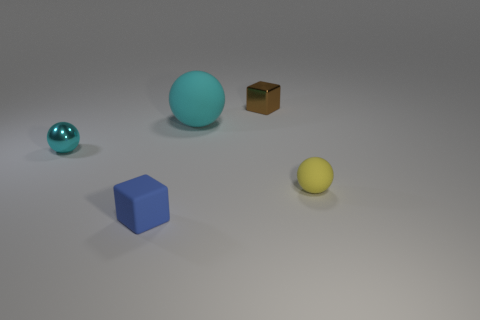There is a metallic block that is the same size as the cyan shiny ball; what is its color?
Provide a succinct answer. Brown. Is the large object made of the same material as the small yellow ball?
Give a very brief answer. Yes. There is a tiny sphere right of the small block that is in front of the brown object; what is it made of?
Your answer should be very brief. Rubber. Are there more spheres in front of the cyan rubber object than blue cubes?
Your response must be concise. Yes. What number of other things are the same size as the rubber cube?
Keep it short and to the point. 3. Is the big matte object the same color as the metallic ball?
Your answer should be compact. Yes. What color is the shiny object that is in front of the small metallic thing behind the cyan sphere that is left of the small blue thing?
Your response must be concise. Cyan. How many small cyan metal spheres are to the right of the small rubber thing to the right of the tiny cube behind the small yellow thing?
Offer a terse response. 0. Is there any other thing that has the same color as the tiny shiny cube?
Make the answer very short. No. There is a cyan thing that is on the left side of the rubber block; does it have the same size as the big cyan matte object?
Provide a short and direct response. No. 